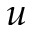Convert formula to latex. <formula><loc_0><loc_0><loc_500><loc_500>u</formula> 